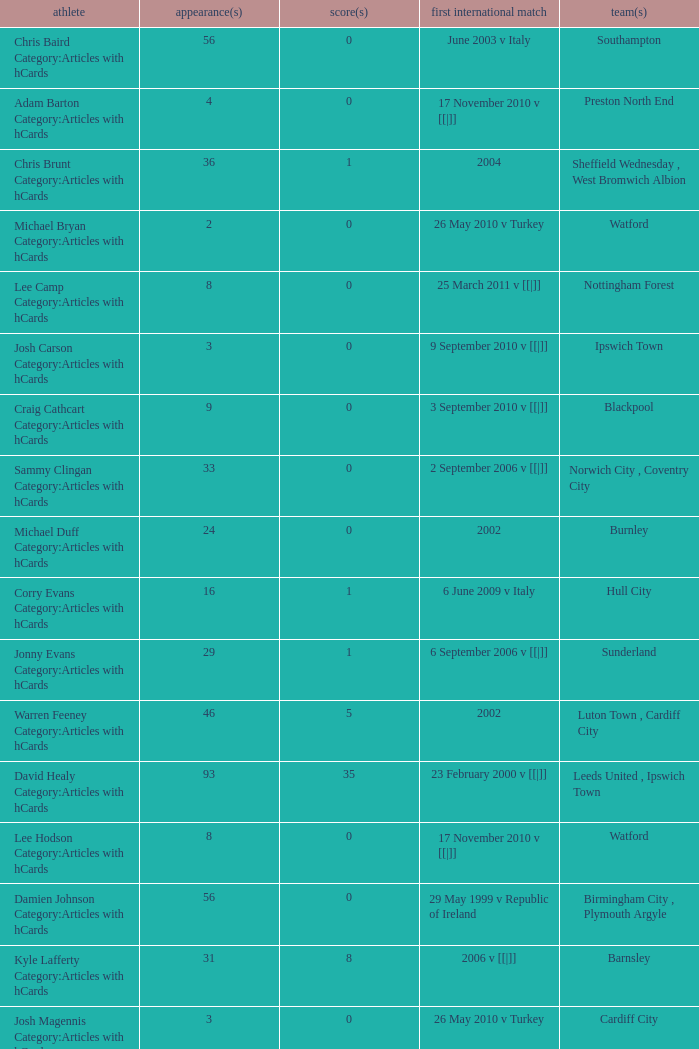How many players had 8 goals? 1.0. 